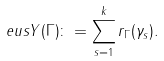<formula> <loc_0><loc_0><loc_500><loc_500>\ e u s Y ( \Gamma ) \colon = \sum _ { s = 1 } ^ { k } r _ { \Gamma } ( \gamma _ { s } ) .</formula> 